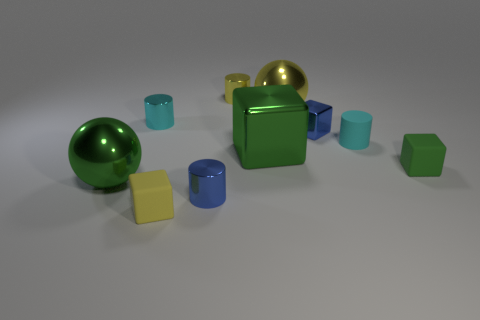Can you describe the interplay of colors and shapes in this image? Certainly, the image displays a harmonious yet diverse composition of colors and shapes. The shapes vary from spherical balls, cubic boxes, to cylindrical containers. The colors are a mixture of vibrant and soft hues, with shades of green, blue, and yellow. This variety creates visual interest and contrast, which makes the scene engaging. The interplay of different shapes and colors can evoke a sense of playfulness or be used to study geometric forms and how they interact with light and shadow in a three-dimensional space. 